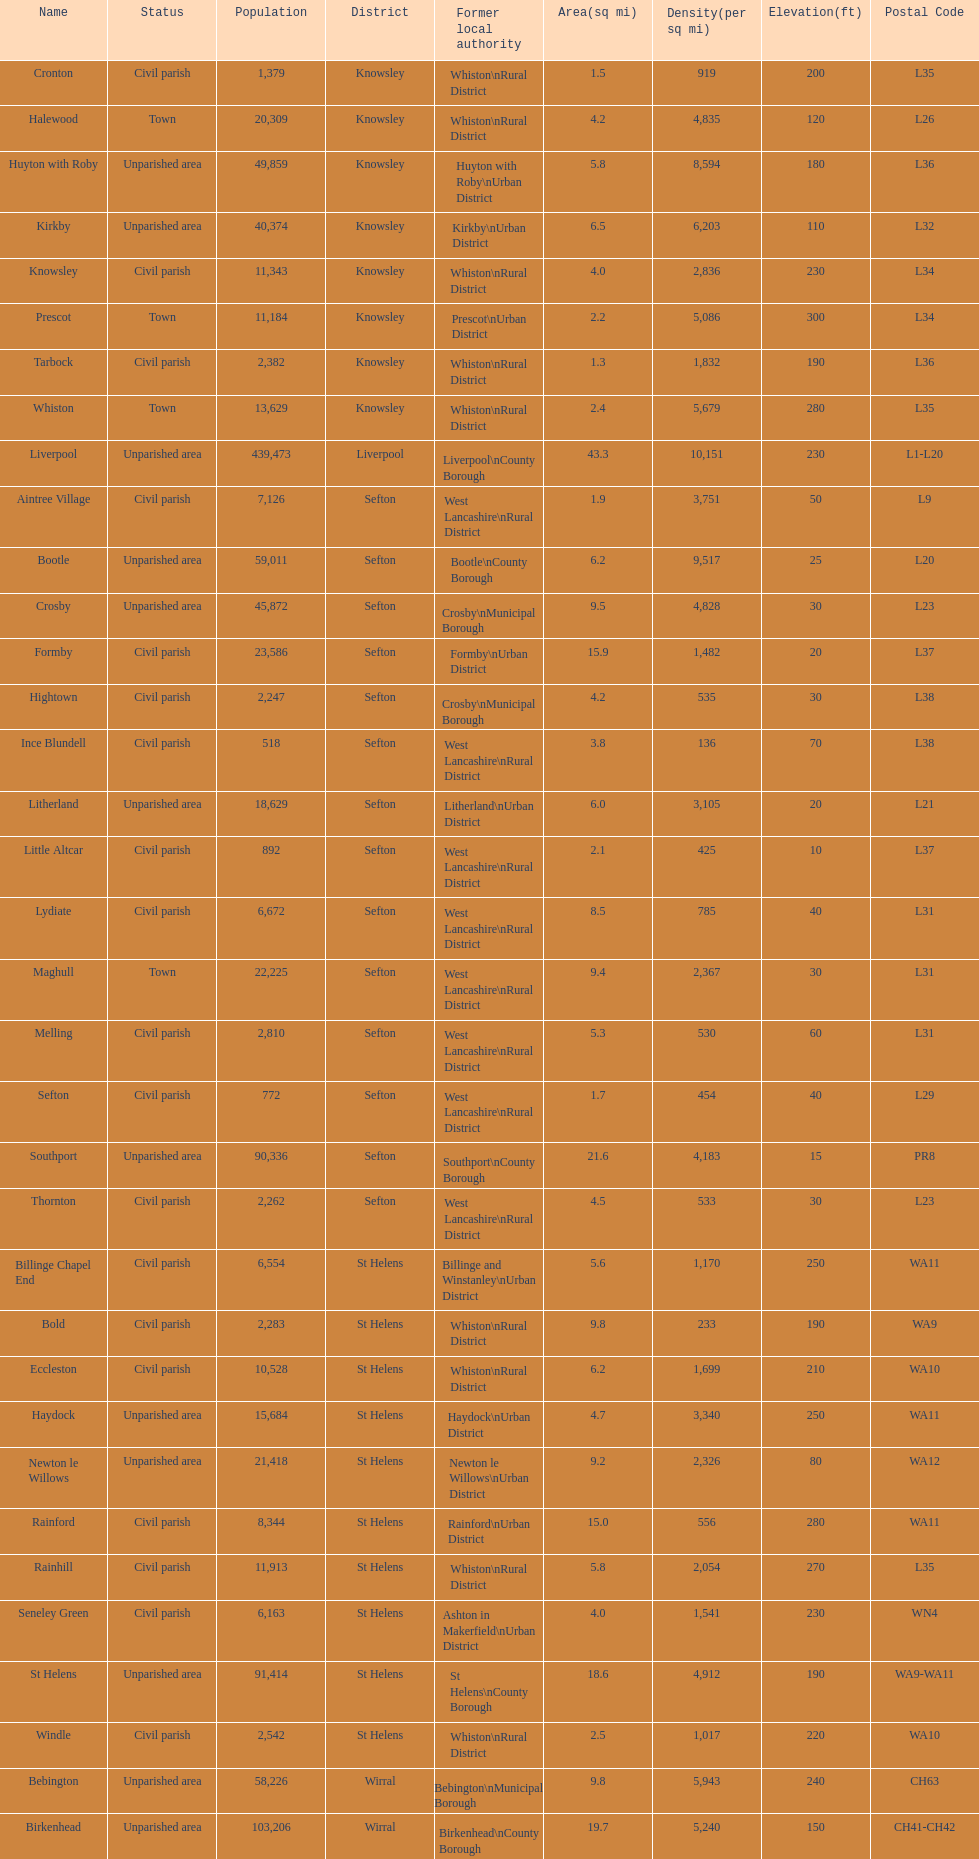Tell me the number of residents in formby. 23,586. 